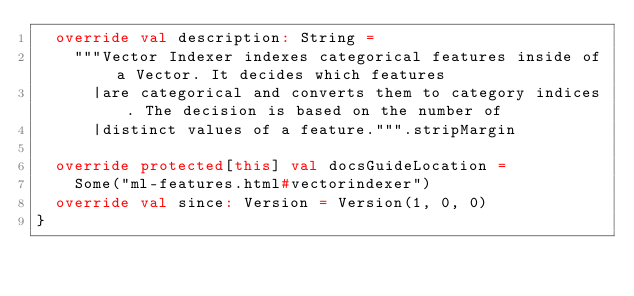Convert code to text. <code><loc_0><loc_0><loc_500><loc_500><_Scala_>  override val description: String =
    """Vector Indexer indexes categorical features inside of a Vector. It decides which features
      |are categorical and converts them to category indices. The decision is based on the number of
      |distinct values of a feature.""".stripMargin

  override protected[this] val docsGuideLocation =
    Some("ml-features.html#vectorindexer")
  override val since: Version = Version(1, 0, 0)
}
</code> 